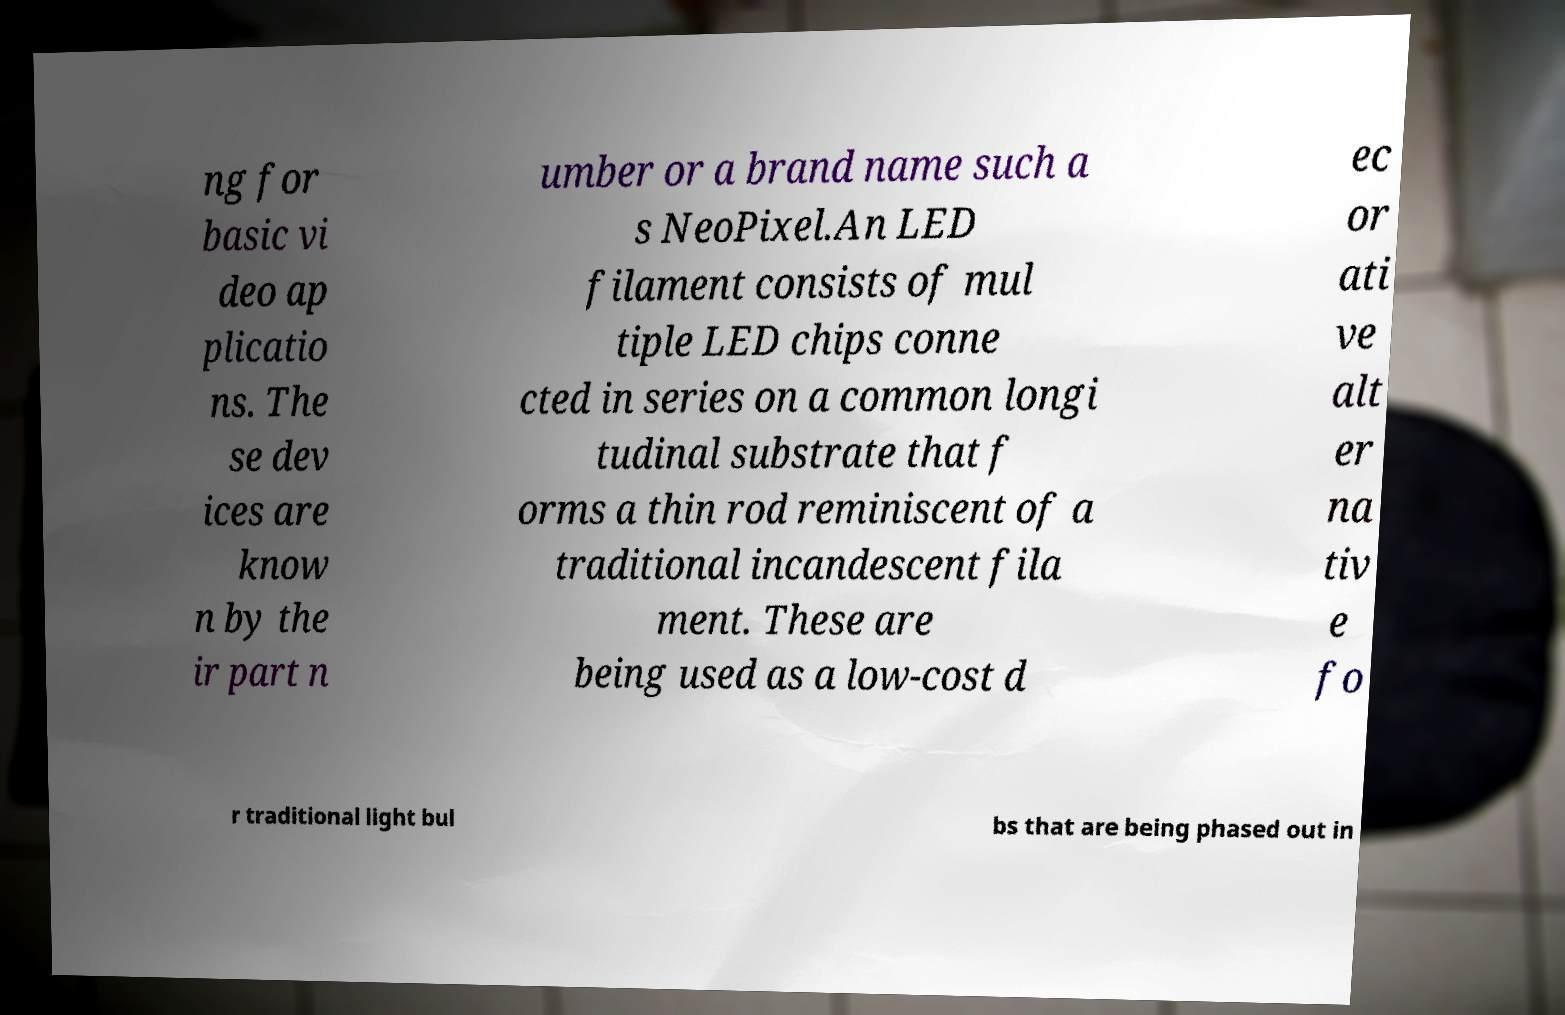I need the written content from this picture converted into text. Can you do that? ng for basic vi deo ap plicatio ns. The se dev ices are know n by the ir part n umber or a brand name such a s NeoPixel.An LED filament consists of mul tiple LED chips conne cted in series on a common longi tudinal substrate that f orms a thin rod reminiscent of a traditional incandescent fila ment. These are being used as a low-cost d ec or ati ve alt er na tiv e fo r traditional light bul bs that are being phased out in 